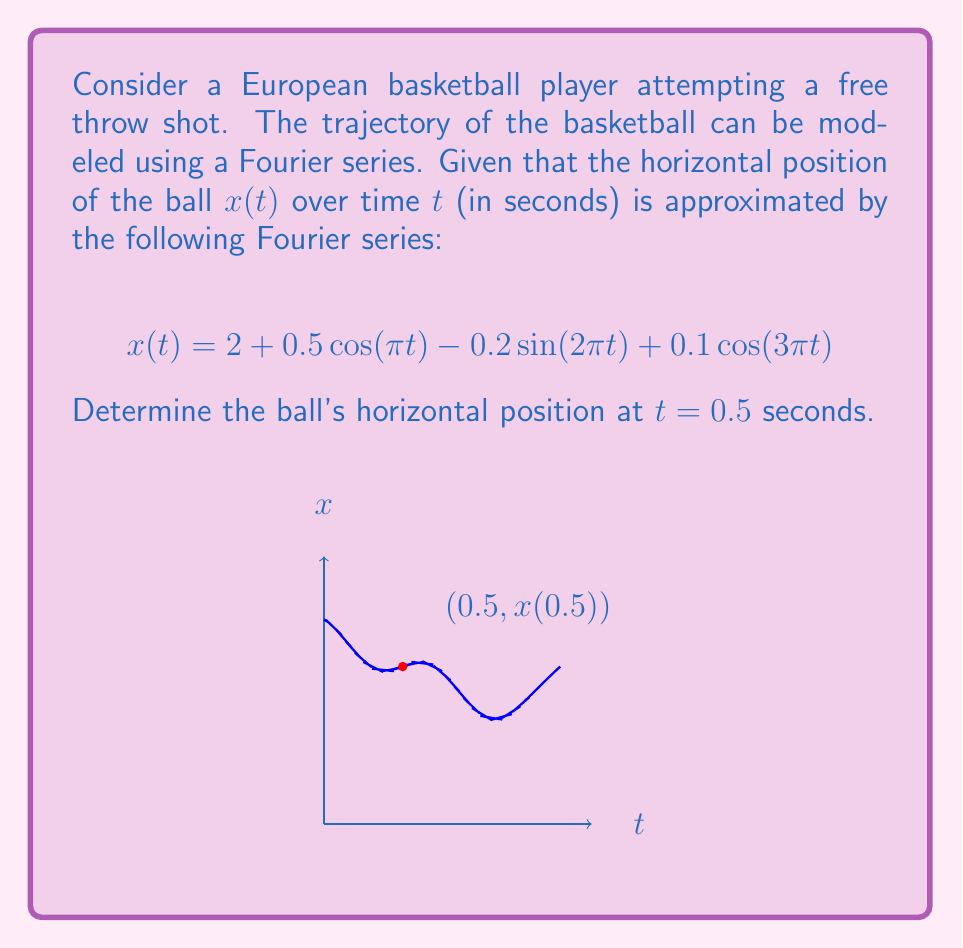Can you answer this question? Let's approach this step-by-step:

1) We are given the Fourier series for $x(t)$:
   $$x(t) = 2 + 0.5 \cos(\pi t) - 0.2 \sin(2\pi t) + 0.1 \cos(3\pi t)$$

2) We need to find $x(0.5)$, so we'll substitute $t = 0.5$ into this equation:
   $$x(0.5) = 2 + 0.5 \cos(\pi \cdot 0.5) - 0.2 \sin(2\pi \cdot 0.5) + 0.1 \cos(3\pi \cdot 0.5)$$

3) Let's evaluate each term:
   - $2$ remains as is
   - $\cos(\pi \cdot 0.5) = \cos(\frac{\pi}{2}) = 0$
   - $\sin(2\pi \cdot 0.5) = \sin(\pi) = 0$
   - $\cos(3\pi \cdot 0.5) = \cos(\frac{3\pi}{2}) = 0$

4) Substituting these values:
   $$x(0.5) = 2 + 0.5 \cdot 0 - 0.2 \cdot 0 + 0.1 \cdot 0 = 2$$

Therefore, at $t = 0.5$ seconds, the horizontal position of the ball is 2 units from the origin.
Answer: $x(0.5) = 2$ 